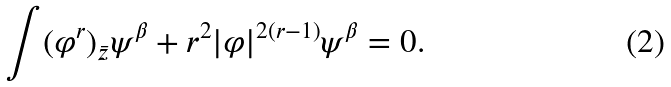Convert formula to latex. <formula><loc_0><loc_0><loc_500><loc_500>\int ( \varphi ^ { r } ) _ { \bar { z } } \psi ^ { \beta } + r ^ { 2 } | \varphi | ^ { 2 ( r - 1 ) } \psi ^ { \beta } = 0 .</formula> 